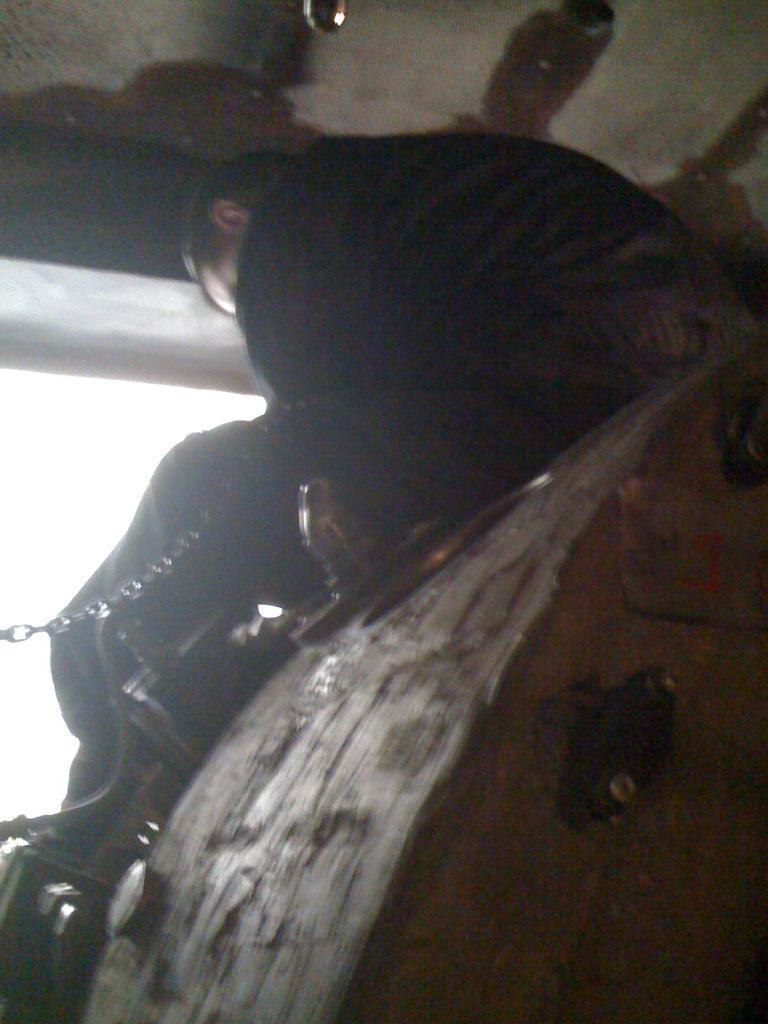How would you summarize this image in a sentence or two? In this image we can see a person sitting on an object. We can also see the chain, ceiling and also the sky. 